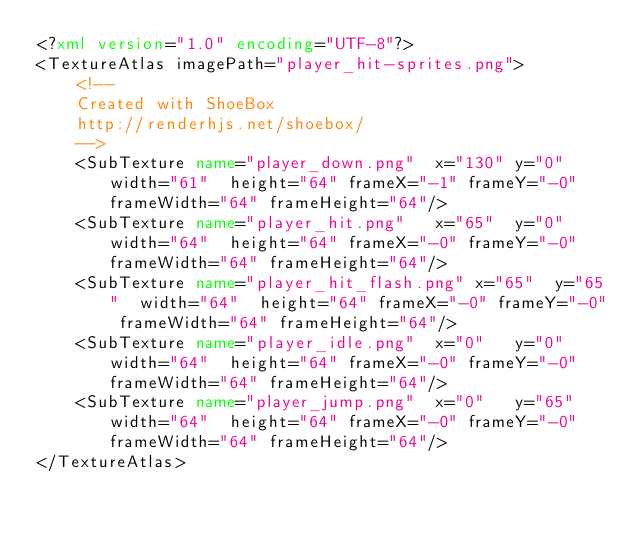<code> <loc_0><loc_0><loc_500><loc_500><_XML_><?xml version="1.0" encoding="UTF-8"?>
<TextureAtlas imagePath="player_hit-sprites.png">
	<!--
	Created with ShoeBox
	http://renderhjs.net/shoebox/
	-->
	<SubTexture name="player_down.png"	x="130"	y="0"	width="61"	height="64" frameX="-1" frameY="-0" frameWidth="64" frameHeight="64"/>
	<SubTexture name="player_hit.png"	x="65"	y="0"	width="64"	height="64" frameX="-0" frameY="-0" frameWidth="64" frameHeight="64"/>
	<SubTexture name="player_hit_flash.png"	x="65"	y="65"	width="64"	height="64" frameX="-0" frameY="-0" frameWidth="64" frameHeight="64"/>
	<SubTexture name="player_idle.png"	x="0"	y="0"	width="64"	height="64" frameX="-0" frameY="-0" frameWidth="64" frameHeight="64"/>
	<SubTexture name="player_jump.png"	x="0"	y="65"	width="64"	height="64" frameX="-0" frameY="-0" frameWidth="64" frameHeight="64"/>
</TextureAtlas></code> 